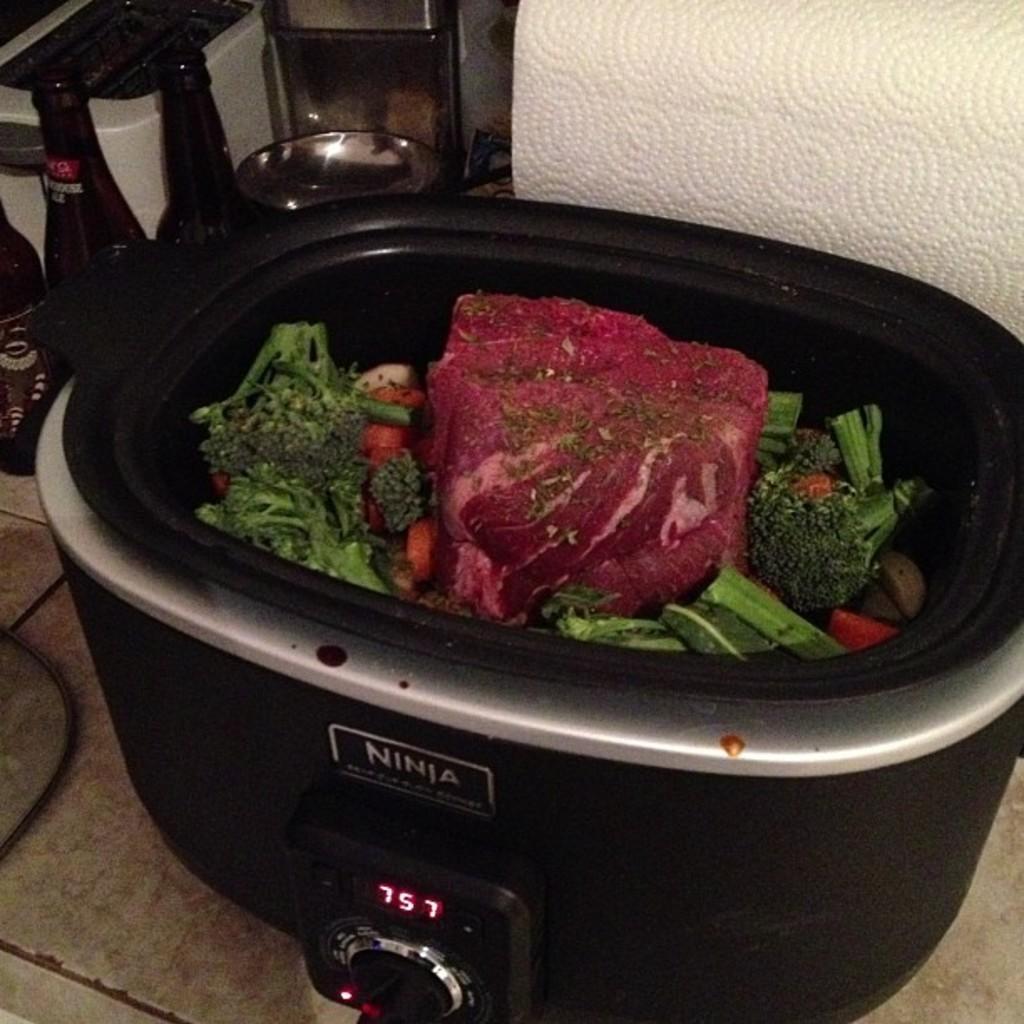In one or two sentences, can you explain what this image depicts? In this picture we can see food items in a bowl, bottle, wire and in the background we can see some objects. 